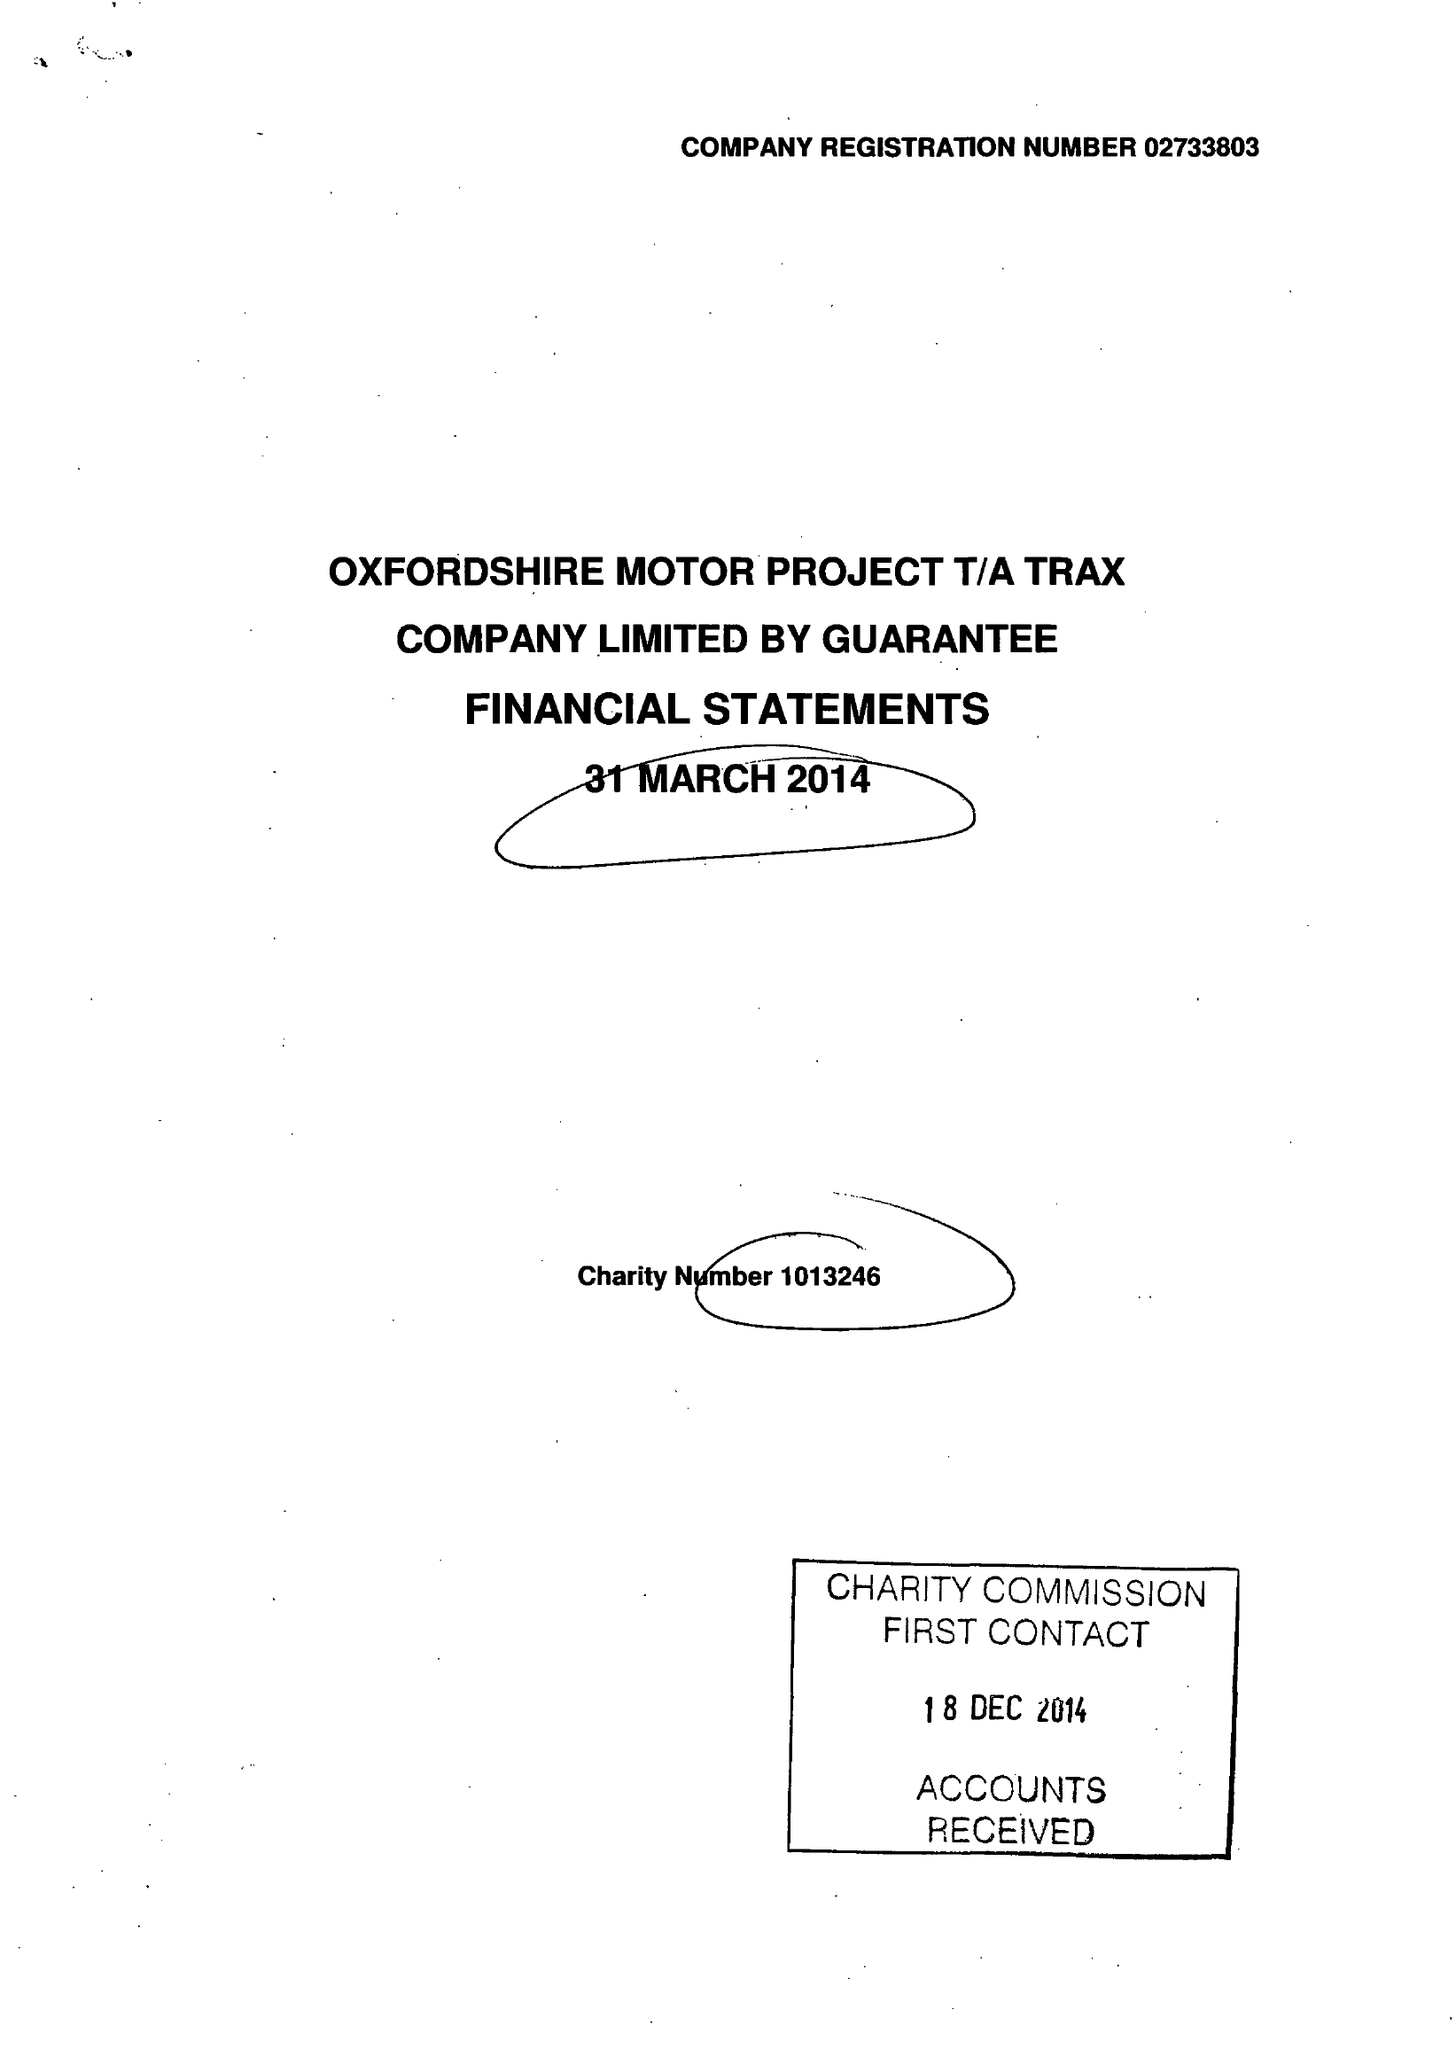What is the value for the report_date?
Answer the question using a single word or phrase. 2014-03-31 